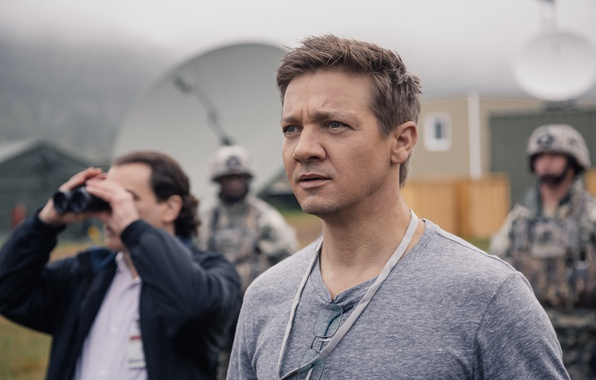Considering the equipment seen, describe a realistic daily operation at this base. A realistic daily operation at this base likely involves coordinating surveillance missions, monitoring satellite feeds, and analyzing intelligence data. Personnel start their day with briefings, distributing tasks that include equipment checks, field communications, and strategic planning. The presence of advanced technology supports a seamless exchange of critical information, crucial for maintaining operational readiness and responding to emerging threats. 